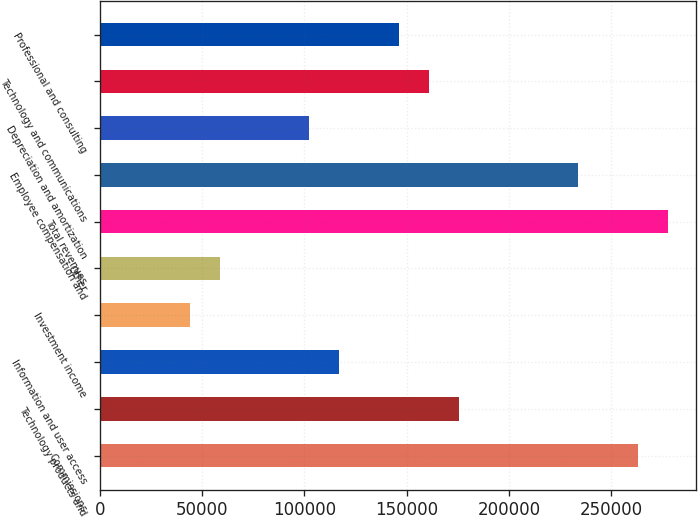<chart> <loc_0><loc_0><loc_500><loc_500><bar_chart><fcel>Commissions<fcel>Technology products and<fcel>Information and user access<fcel>Investment income<fcel>Other<fcel>Total revenues<fcel>Employee compensation and<fcel>Depreciation and amortization<fcel>Technology and communications<fcel>Professional and consulting<nl><fcel>263210<fcel>175474<fcel>116982<fcel>43868.6<fcel>58491.4<fcel>277833<fcel>233965<fcel>102360<fcel>160851<fcel>146228<nl></chart> 